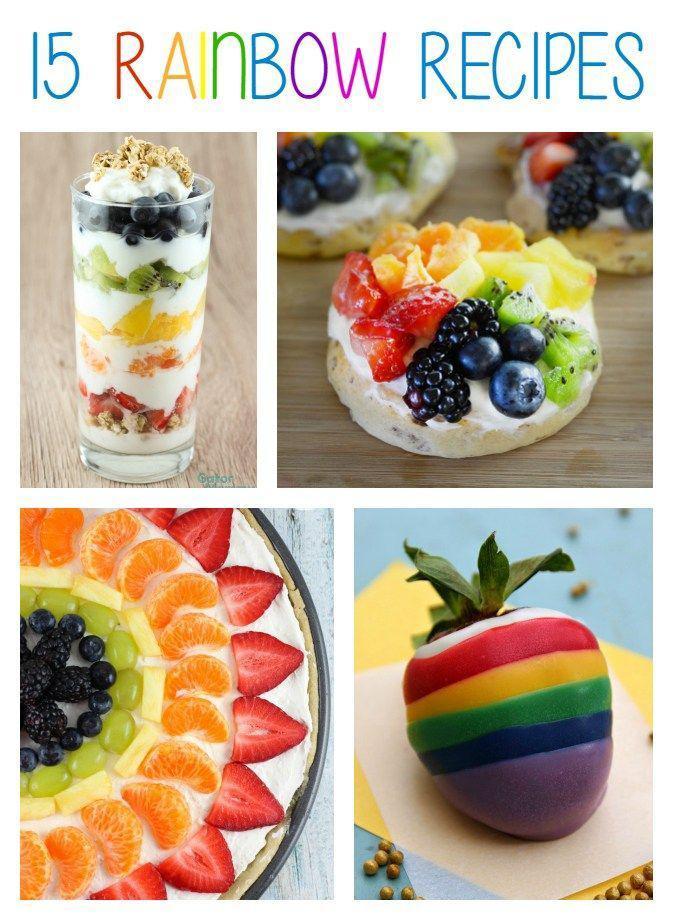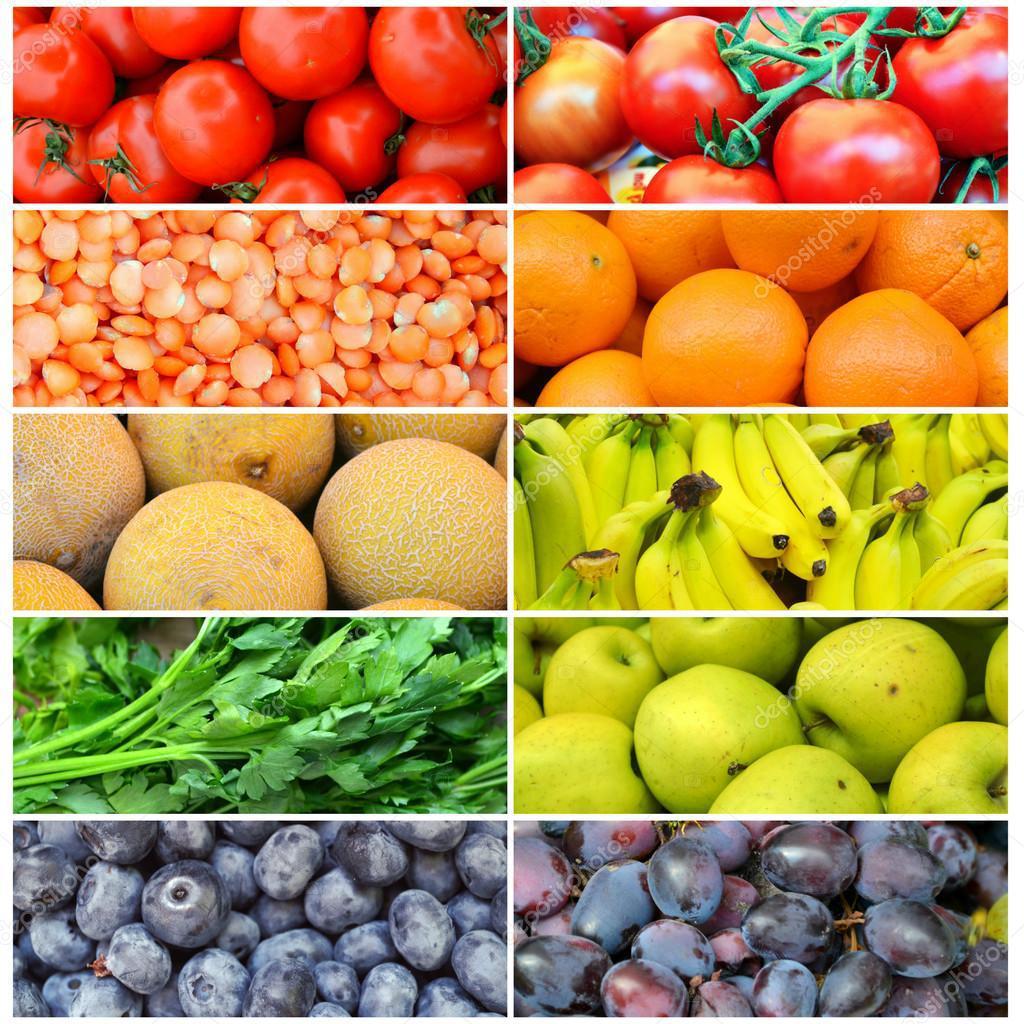The first image is the image on the left, the second image is the image on the right. Examine the images to the left and right. Is the description "Right image shows fruit forming half-circle rainbow shape without use of spears." accurate? Answer yes or no. No. 